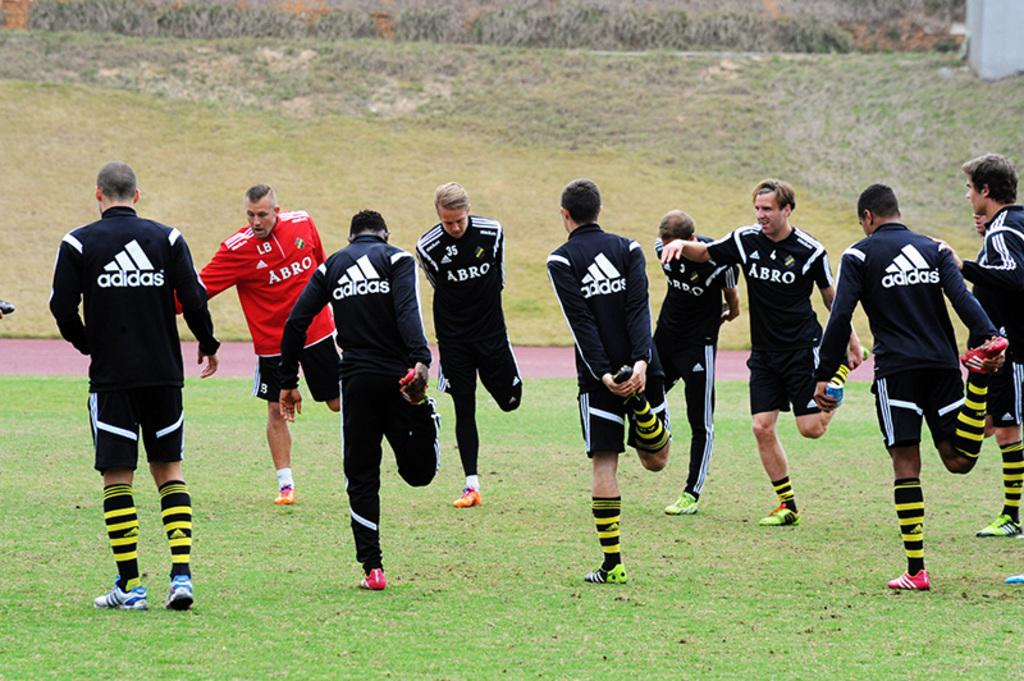<image>
Summarize the visual content of the image. Several men wearing clothing with the word Adidas on the back are standing on a grass fieldd 